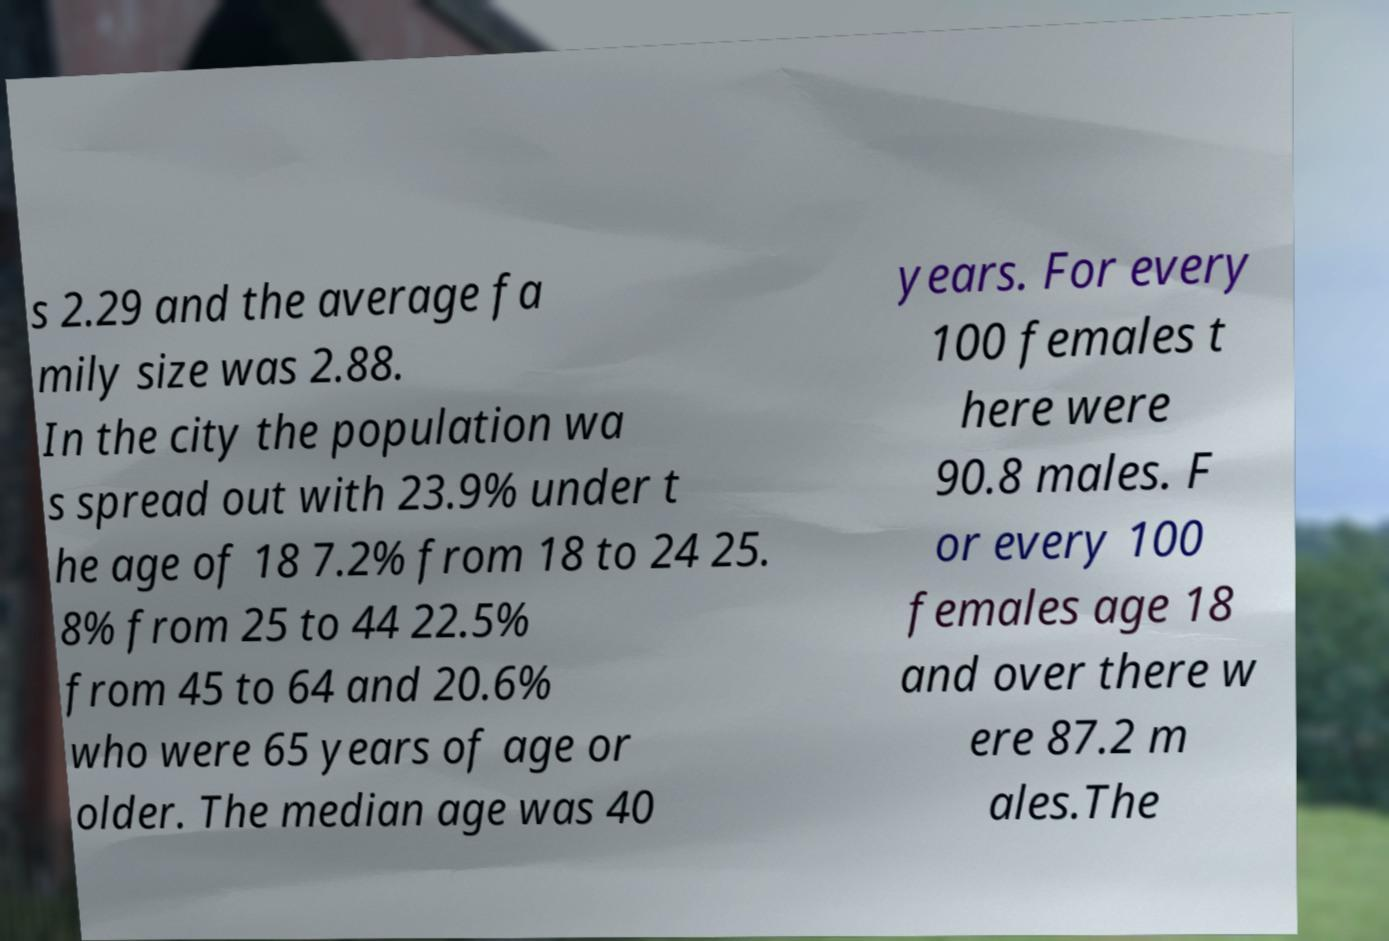I need the written content from this picture converted into text. Can you do that? s 2.29 and the average fa mily size was 2.88. In the city the population wa s spread out with 23.9% under t he age of 18 7.2% from 18 to 24 25. 8% from 25 to 44 22.5% from 45 to 64 and 20.6% who were 65 years of age or older. The median age was 40 years. For every 100 females t here were 90.8 males. F or every 100 females age 18 and over there w ere 87.2 m ales.The 